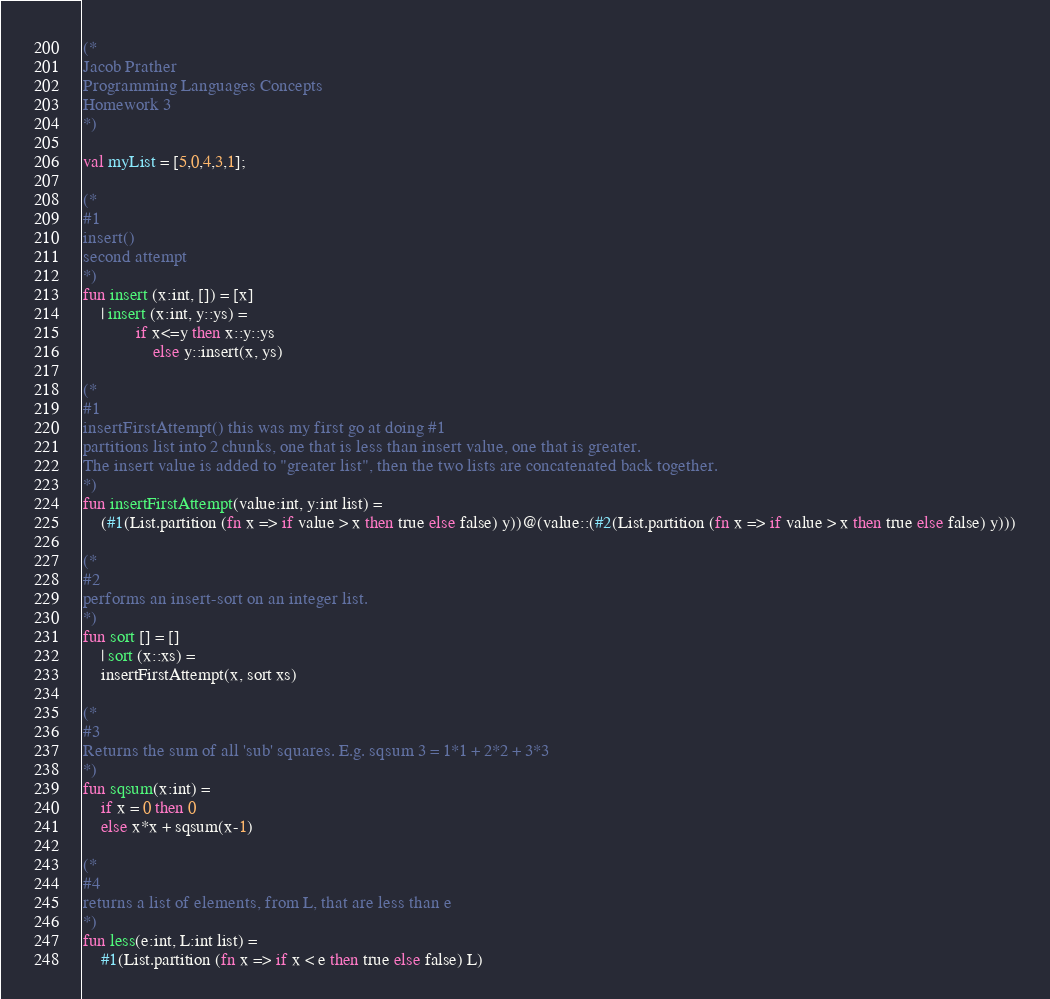Convert code to text. <code><loc_0><loc_0><loc_500><loc_500><_SML_>(*
Jacob Prather
Programming Languages Concepts
Homework 3
*)

val myList = [5,0,4,3,1];

(*
#1
insert()
second attempt
*)
fun insert (x:int, []) = [x]
	| insert (x:int, y::ys) =
        	if x<=y then x::y::ys
                else y::insert(x, ys)

(*
#1 
insertFirstAttempt() this was my first go at doing #1
partitions list into 2 chunks, one that is less than insert value, one that is greater.
The insert value is added to "greater list", then the two lists are concatenated back together.
*)
fun insertFirstAttempt(value:int, y:int list) =
	(#1(List.partition (fn x => if value > x then true else false) y))@(value::(#2(List.partition (fn x => if value > x then true else false) y)))

(*
#2
performs an insert-sort on an integer list.
*)
fun sort [] = []
	| sort (x::xs) =
	insertFirstAttempt(x, sort xs)

(*
#3
Returns the sum of all 'sub' squares. E.g. sqsum 3 = 1*1 + 2*2 + 3*3
*)
fun sqsum(x:int) =
	if x = 0 then 0
	else x*x + sqsum(x-1)

(*
#4
returns a list of elements, from L, that are less than e
*)
fun less(e:int, L:int list) = 
	#1(List.partition (fn x => if x < e then true else false) L)
</code> 